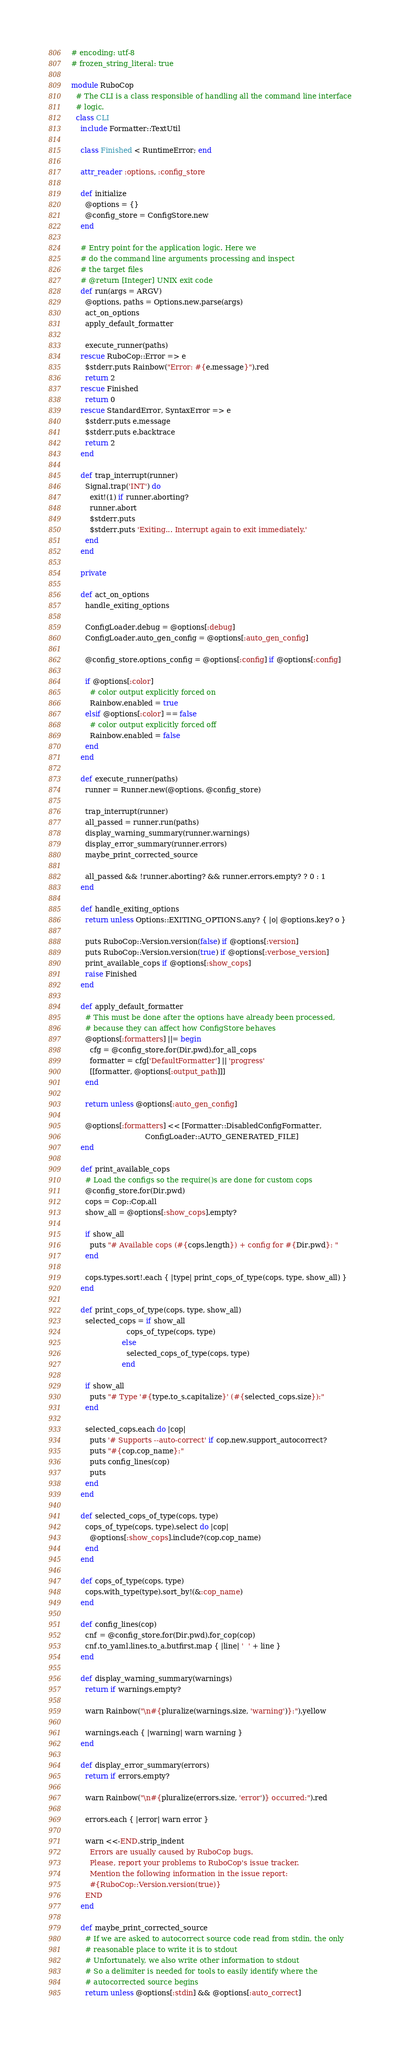<code> <loc_0><loc_0><loc_500><loc_500><_Ruby_># encoding: utf-8
# frozen_string_literal: true

module RuboCop
  # The CLI is a class responsible of handling all the command line interface
  # logic.
  class CLI
    include Formatter::TextUtil

    class Finished < RuntimeError; end

    attr_reader :options, :config_store

    def initialize
      @options = {}
      @config_store = ConfigStore.new
    end

    # Entry point for the application logic. Here we
    # do the command line arguments processing and inspect
    # the target files
    # @return [Integer] UNIX exit code
    def run(args = ARGV)
      @options, paths = Options.new.parse(args)
      act_on_options
      apply_default_formatter

      execute_runner(paths)
    rescue RuboCop::Error => e
      $stderr.puts Rainbow("Error: #{e.message}").red
      return 2
    rescue Finished
      return 0
    rescue StandardError, SyntaxError => e
      $stderr.puts e.message
      $stderr.puts e.backtrace
      return 2
    end

    def trap_interrupt(runner)
      Signal.trap('INT') do
        exit!(1) if runner.aborting?
        runner.abort
        $stderr.puts
        $stderr.puts 'Exiting... Interrupt again to exit immediately.'
      end
    end

    private

    def act_on_options
      handle_exiting_options

      ConfigLoader.debug = @options[:debug]
      ConfigLoader.auto_gen_config = @options[:auto_gen_config]

      @config_store.options_config = @options[:config] if @options[:config]

      if @options[:color]
        # color output explicitly forced on
        Rainbow.enabled = true
      elsif @options[:color] == false
        # color output explicitly forced off
        Rainbow.enabled = false
      end
    end

    def execute_runner(paths)
      runner = Runner.new(@options, @config_store)

      trap_interrupt(runner)
      all_passed = runner.run(paths)
      display_warning_summary(runner.warnings)
      display_error_summary(runner.errors)
      maybe_print_corrected_source

      all_passed && !runner.aborting? && runner.errors.empty? ? 0 : 1
    end

    def handle_exiting_options
      return unless Options::EXITING_OPTIONS.any? { |o| @options.key? o }

      puts RuboCop::Version.version(false) if @options[:version]
      puts RuboCop::Version.version(true) if @options[:verbose_version]
      print_available_cops if @options[:show_cops]
      raise Finished
    end

    def apply_default_formatter
      # This must be done after the options have already been processed,
      # because they can affect how ConfigStore behaves
      @options[:formatters] ||= begin
        cfg = @config_store.for(Dir.pwd).for_all_cops
        formatter = cfg['DefaultFormatter'] || 'progress'
        [[formatter, @options[:output_path]]]
      end

      return unless @options[:auto_gen_config]

      @options[:formatters] << [Formatter::DisabledConfigFormatter,
                                ConfigLoader::AUTO_GENERATED_FILE]
    end

    def print_available_cops
      # Load the configs so the require()s are done for custom cops
      @config_store.for(Dir.pwd)
      cops = Cop::Cop.all
      show_all = @options[:show_cops].empty?

      if show_all
        puts "# Available cops (#{cops.length}) + config for #{Dir.pwd}: "
      end

      cops.types.sort!.each { |type| print_cops_of_type(cops, type, show_all) }
    end

    def print_cops_of_type(cops, type, show_all)
      selected_cops = if show_all
                        cops_of_type(cops, type)
                      else
                        selected_cops_of_type(cops, type)
                      end

      if show_all
        puts "# Type '#{type.to_s.capitalize}' (#{selected_cops.size}):"
      end

      selected_cops.each do |cop|
        puts '# Supports --auto-correct' if cop.new.support_autocorrect?
        puts "#{cop.cop_name}:"
        puts config_lines(cop)
        puts
      end
    end

    def selected_cops_of_type(cops, type)
      cops_of_type(cops, type).select do |cop|
        @options[:show_cops].include?(cop.cop_name)
      end
    end

    def cops_of_type(cops, type)
      cops.with_type(type).sort_by!(&:cop_name)
    end

    def config_lines(cop)
      cnf = @config_store.for(Dir.pwd).for_cop(cop)
      cnf.to_yaml.lines.to_a.butfirst.map { |line| '  ' + line }
    end

    def display_warning_summary(warnings)
      return if warnings.empty?

      warn Rainbow("\n#{pluralize(warnings.size, 'warning')}:").yellow

      warnings.each { |warning| warn warning }
    end

    def display_error_summary(errors)
      return if errors.empty?

      warn Rainbow("\n#{pluralize(errors.size, 'error')} occurred:").red

      errors.each { |error| warn error }

      warn <<-END.strip_indent
        Errors are usually caused by RuboCop bugs.
        Please, report your problems to RuboCop's issue tracker.
        Mention the following information in the issue report:
        #{RuboCop::Version.version(true)}
      END
    end

    def maybe_print_corrected_source
      # If we are asked to autocorrect source code read from stdin, the only
      # reasonable place to write it is to stdout
      # Unfortunately, we also write other information to stdout
      # So a delimiter is needed for tools to easily identify where the
      # autocorrected source begins
      return unless @options[:stdin] && @options[:auto_correct]</code> 